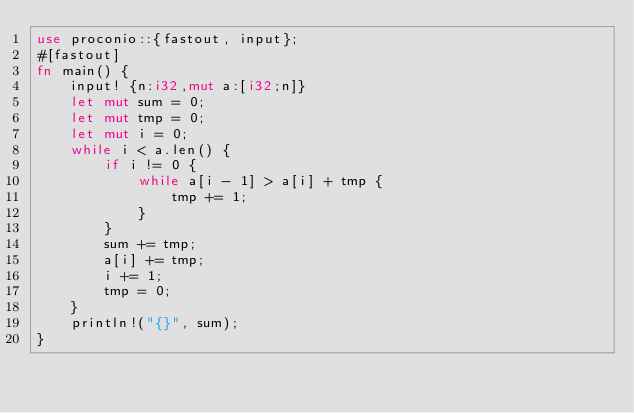<code> <loc_0><loc_0><loc_500><loc_500><_Rust_>use proconio::{fastout, input};
#[fastout]
fn main() {
    input! {n:i32,mut a:[i32;n]}
    let mut sum = 0;
    let mut tmp = 0;
    let mut i = 0;
    while i < a.len() {
        if i != 0 {
            while a[i - 1] > a[i] + tmp {
                tmp += 1;
            }
        }
        sum += tmp;
        a[i] += tmp;
        i += 1;
        tmp = 0;
    }
    println!("{}", sum);
}
</code> 